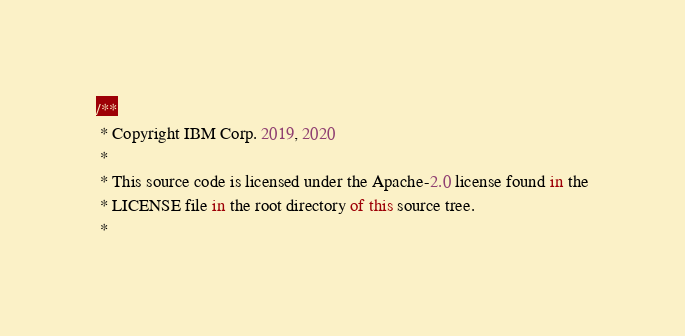<code> <loc_0><loc_0><loc_500><loc_500><_JavaScript_>/**
 * Copyright IBM Corp. 2019, 2020
 *
 * This source code is licensed under the Apache-2.0 license found in the
 * LICENSE file in the root directory of this source tree.
 *</code> 